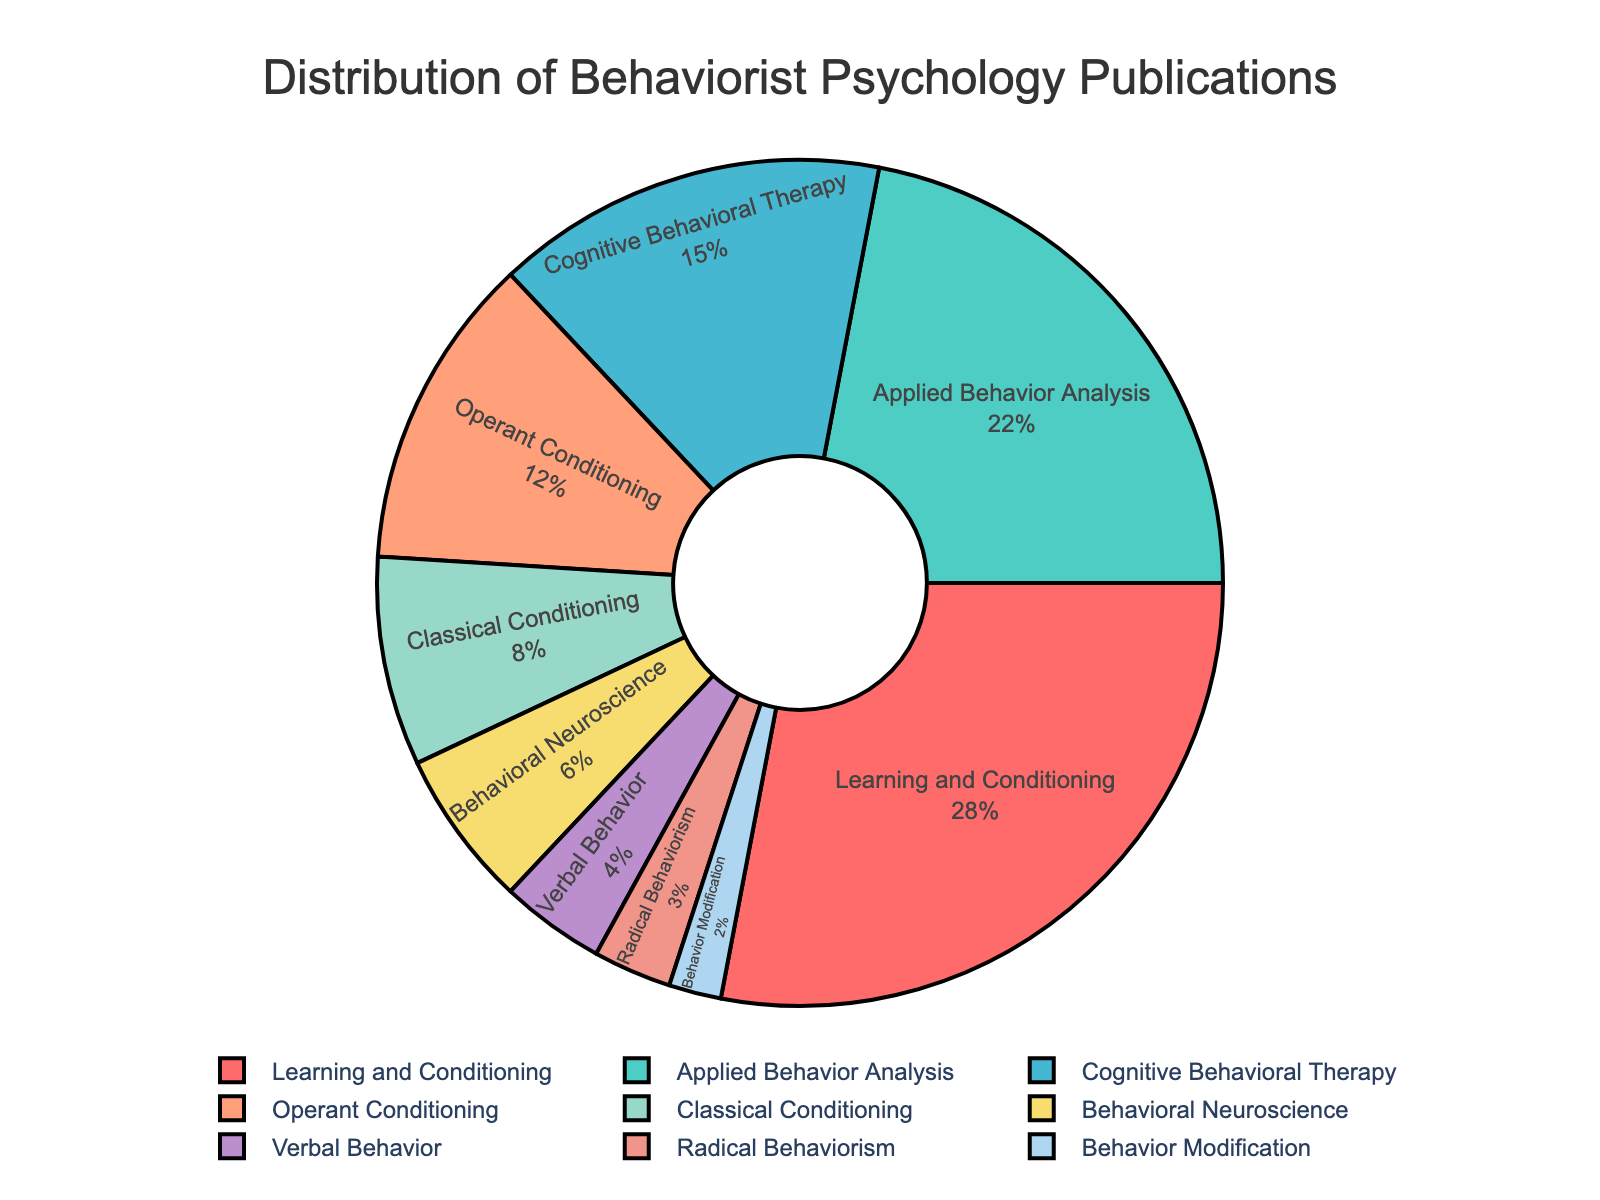Which subfield represents the largest portion of behaviorist psychology publications? The largest portion is represented by the subfield with the highest percentage. In the figure, "Learning and Conditioning" holds 28%, which is the highest.
Answer: Learning and Conditioning What percentage of behaviorist psychology publications are related to "Applied Behavior Analysis" and "Cognitive Behavioral Therapy" combined? By adding the percentages of "Applied Behavior Analysis" (22%) and "Cognitive Behavioral Therapy" (15%), you get 37%.
Answer: 37% How does the percentage of "Operant Conditioning" publications compare to "Classical Conditioning"? The percentage of "Operant Conditioning" publications is 12%, whereas "Classical Conditioning" is 8%. Therefore, "Operant Conditioning" has a higher percentage.
Answer: Operant Conditioning has a higher percentage Which subfield has the least representation in the chart? The subfield with the smallest percentage value represents the least. "Behavior Modification" has the least representation at 2%.
Answer: Behavior Modification What is the combined percentage of publications in "Behavioral Neuroscience" and "Verbal Behavior"? To find the combined percentage, sum "Behavioral Neuroscience" (6%) and "Verbal Behavior" (4%), resulting in 10%.
Answer: 10% How many subfields have a percentage of 10% or higher? Counting the subfields with percentages equal to or greater than 10%: "Learning and Conditioning" (28%), "Applied Behavior Analysis" (22%), "Cognitive Behavioral Therapy" (15%), and "Operant Conditioning" (12%), there are four subfields.
Answer: Four What percentage is represented by subfields with less than 5% each? Sum the percentages for "Radical Behaviorism" (3%) and "Behavior Modification" (2%) to get 5%.
Answer: 5% Among the subfields, which one is represented by a blue color slice in the pie chart? By eliminating other colors associated with higher percentages, "Operant Conditioning" with a percentage of 12% fits the blue color slice.
Answer: Operant Conditioning If "Learning and Conditioning" and "Applied Behavior Analysis" were merged, what would their combined percentage be? Adding the percentage of "Learning and Conditioning" (28%) and "Applied Behavior Analysis" (22%), their combined percentage would be 50%.
Answer: 50% What is the difference in publication percentages between "Cognitive Behavioral Therapy" and "Behavioral Neuroscience"? Subtract the percentage for "Behavioral Neuroscience" (6%) from "Cognitive Behavioral Therapy" (15%), giving a difference of 9%.
Answer: 9% 